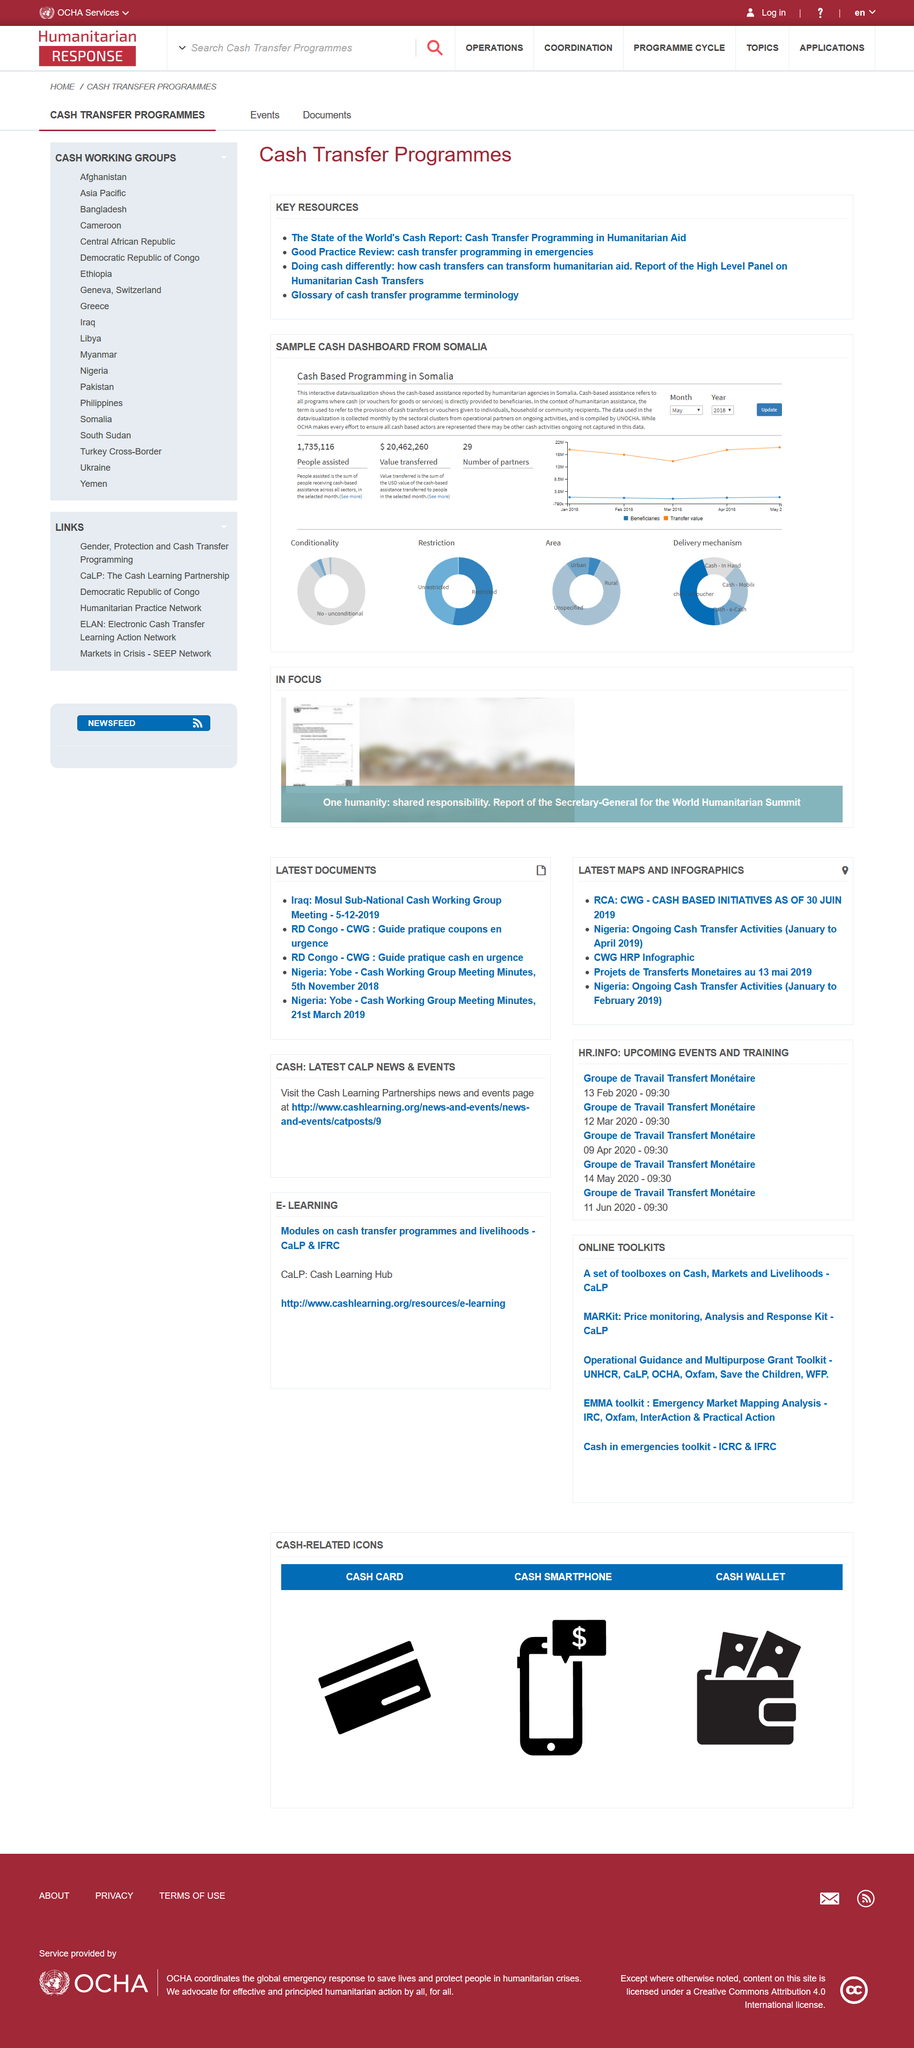Outline some significant characteristics in this image. The value of transferred Cash Based Programming is estimated to be $20,462,260 USD. The conversation concerns the cash-based programming of a country known as Somalia. The four pie charts show the distribution of conditionality, restriction, area, and delivery mechanism of the interventions in the studies reviewed. 